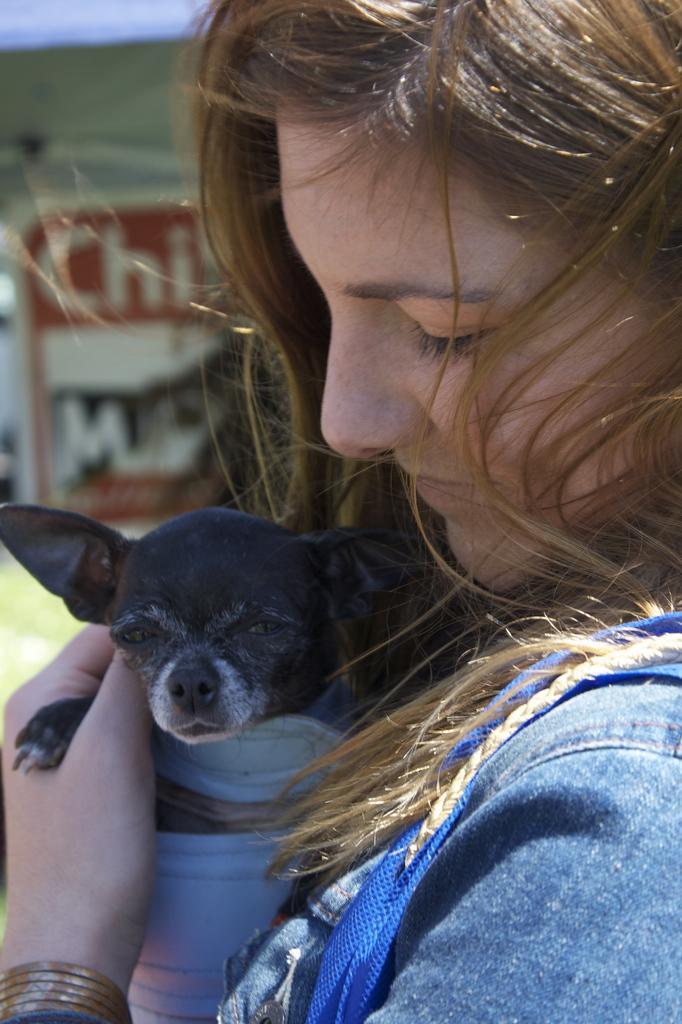Describe this image in one or two sentences. In this picture is carrying a dog. she is wearing a denim jacket. In the background there is a banner. 